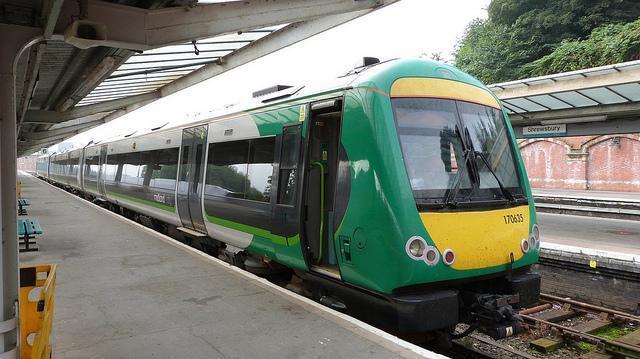How many people are surfing?
Give a very brief answer. 0. 